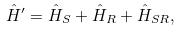Convert formula to latex. <formula><loc_0><loc_0><loc_500><loc_500>\hat { H } ^ { \prime } = \hat { H } _ { S } + \hat { H } _ { R } + \hat { H } _ { S R } ,</formula> 